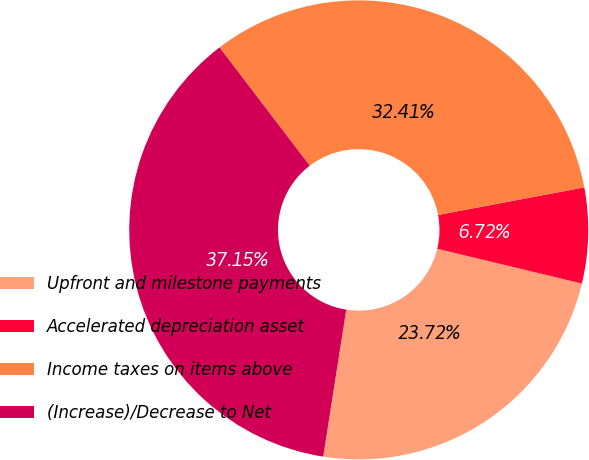Convert chart. <chart><loc_0><loc_0><loc_500><loc_500><pie_chart><fcel>Upfront and milestone payments<fcel>Accelerated depreciation asset<fcel>Income taxes on items above<fcel>(Increase)/Decrease to Net<nl><fcel>23.72%<fcel>6.72%<fcel>32.41%<fcel>37.15%<nl></chart> 